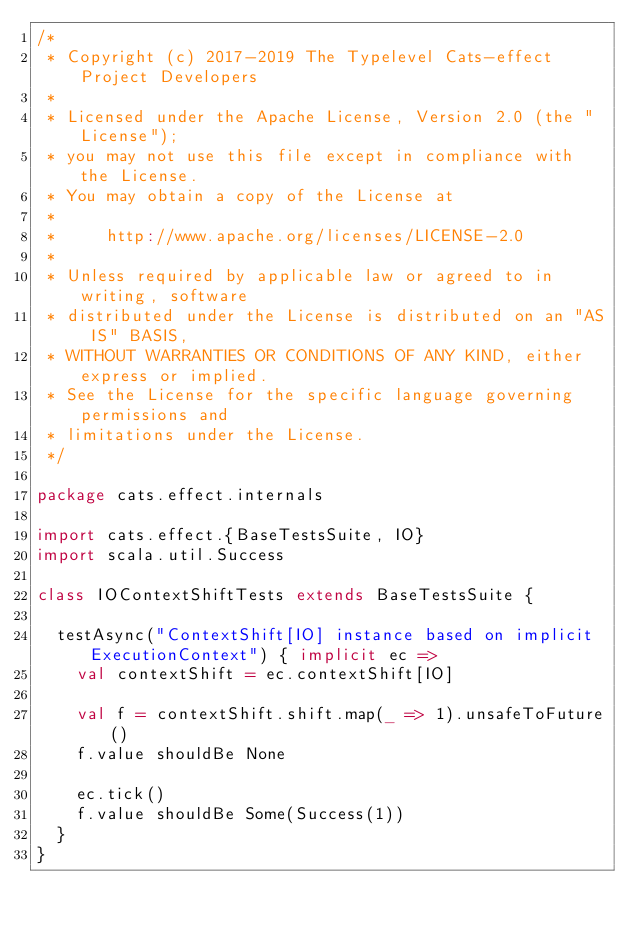Convert code to text. <code><loc_0><loc_0><loc_500><loc_500><_Scala_>/*
 * Copyright (c) 2017-2019 The Typelevel Cats-effect Project Developers
 *
 * Licensed under the Apache License, Version 2.0 (the "License");
 * you may not use this file except in compliance with the License.
 * You may obtain a copy of the License at
 *
 *     http://www.apache.org/licenses/LICENSE-2.0
 *
 * Unless required by applicable law or agreed to in writing, software
 * distributed under the License is distributed on an "AS IS" BASIS,
 * WITHOUT WARRANTIES OR CONDITIONS OF ANY KIND, either express or implied.
 * See the License for the specific language governing permissions and
 * limitations under the License.
 */

package cats.effect.internals

import cats.effect.{BaseTestsSuite, IO}
import scala.util.Success

class IOContextShiftTests extends BaseTestsSuite {
 
  testAsync("ContextShift[IO] instance based on implicit ExecutionContext") { implicit ec =>
    val contextShift = ec.contextShift[IO]

    val f = contextShift.shift.map(_ => 1).unsafeToFuture()
    f.value shouldBe None

    ec.tick()
    f.value shouldBe Some(Success(1))
  }
}
</code> 